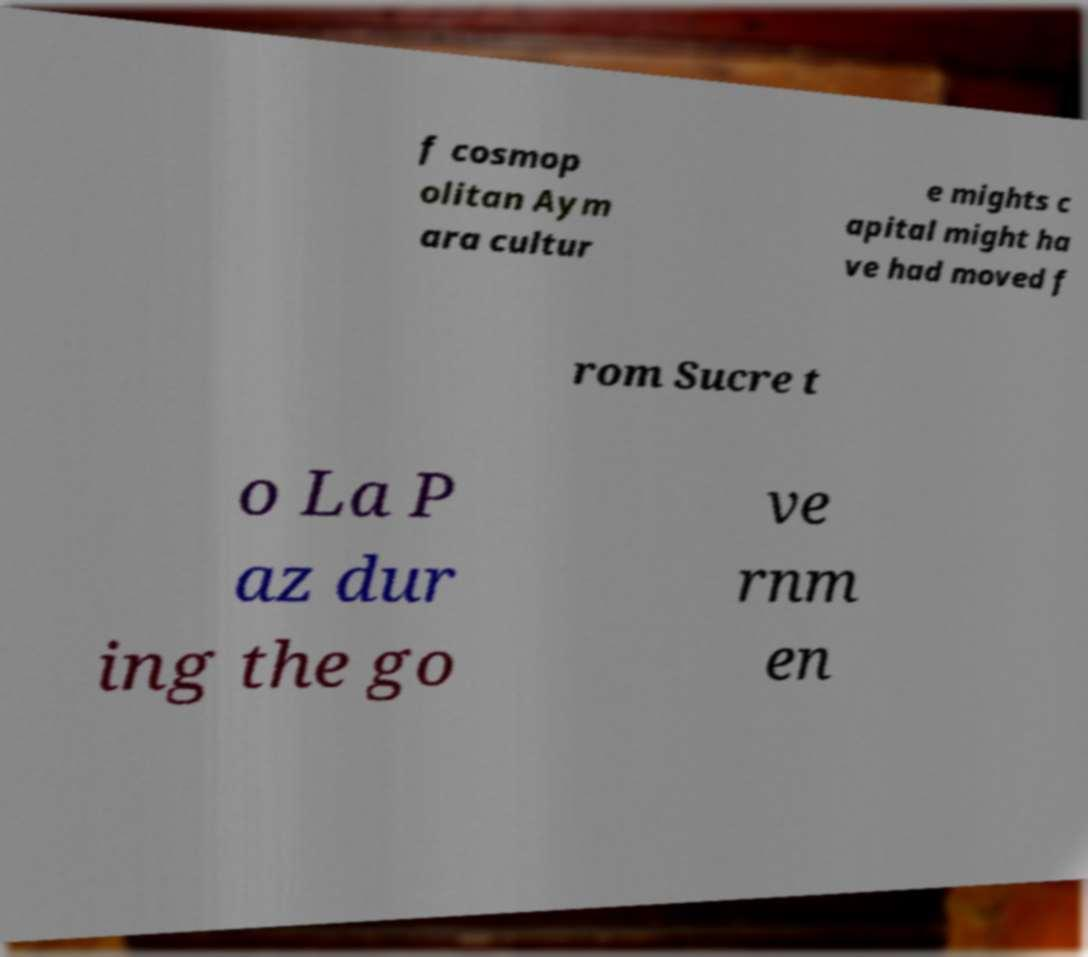Could you assist in decoding the text presented in this image and type it out clearly? f cosmop olitan Aym ara cultur e mights c apital might ha ve had moved f rom Sucre t o La P az dur ing the go ve rnm en 